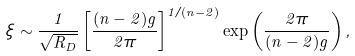<formula> <loc_0><loc_0><loc_500><loc_500>\xi \sim \frac { 1 } { \sqrt { R _ { D } } } \left [ \frac { ( n - 2 ) g } { 2 \pi } \right ] ^ { 1 / ( n - 2 ) } \exp \left ( \frac { 2 \pi } { ( n - 2 ) g } \right ) ,</formula> 